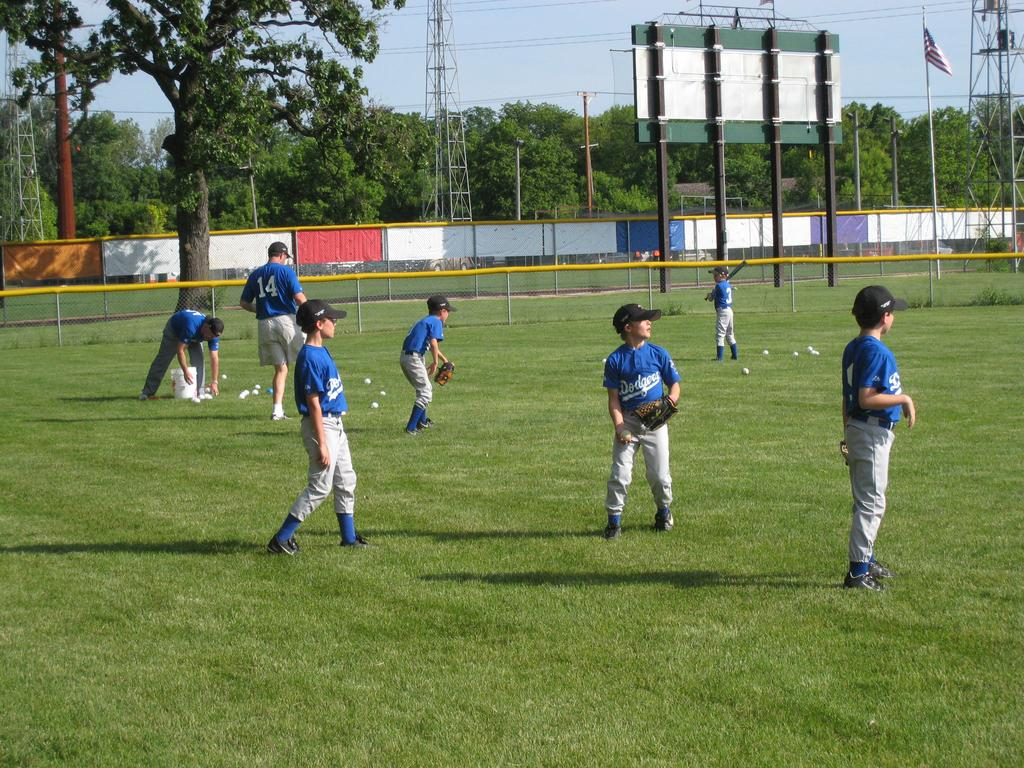<image>
Create a compact narrative representing the image presented. the team name Dodgers is on some of the jerseys 